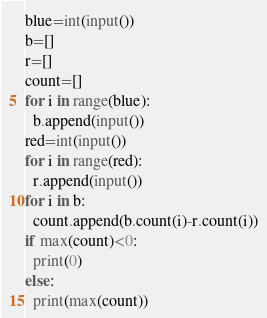Convert code to text. <code><loc_0><loc_0><loc_500><loc_500><_Python_>blue=int(input())
b=[]
r=[]
count=[]
for i in range(blue):
  b.append(input())
red=int(input())
for i in range(red):
  r.append(input())
for i in b:
  count.append(b.count(i)-r.count(i))
if max(count)<0:
  print(0)
else:
  print(max(count))</code> 